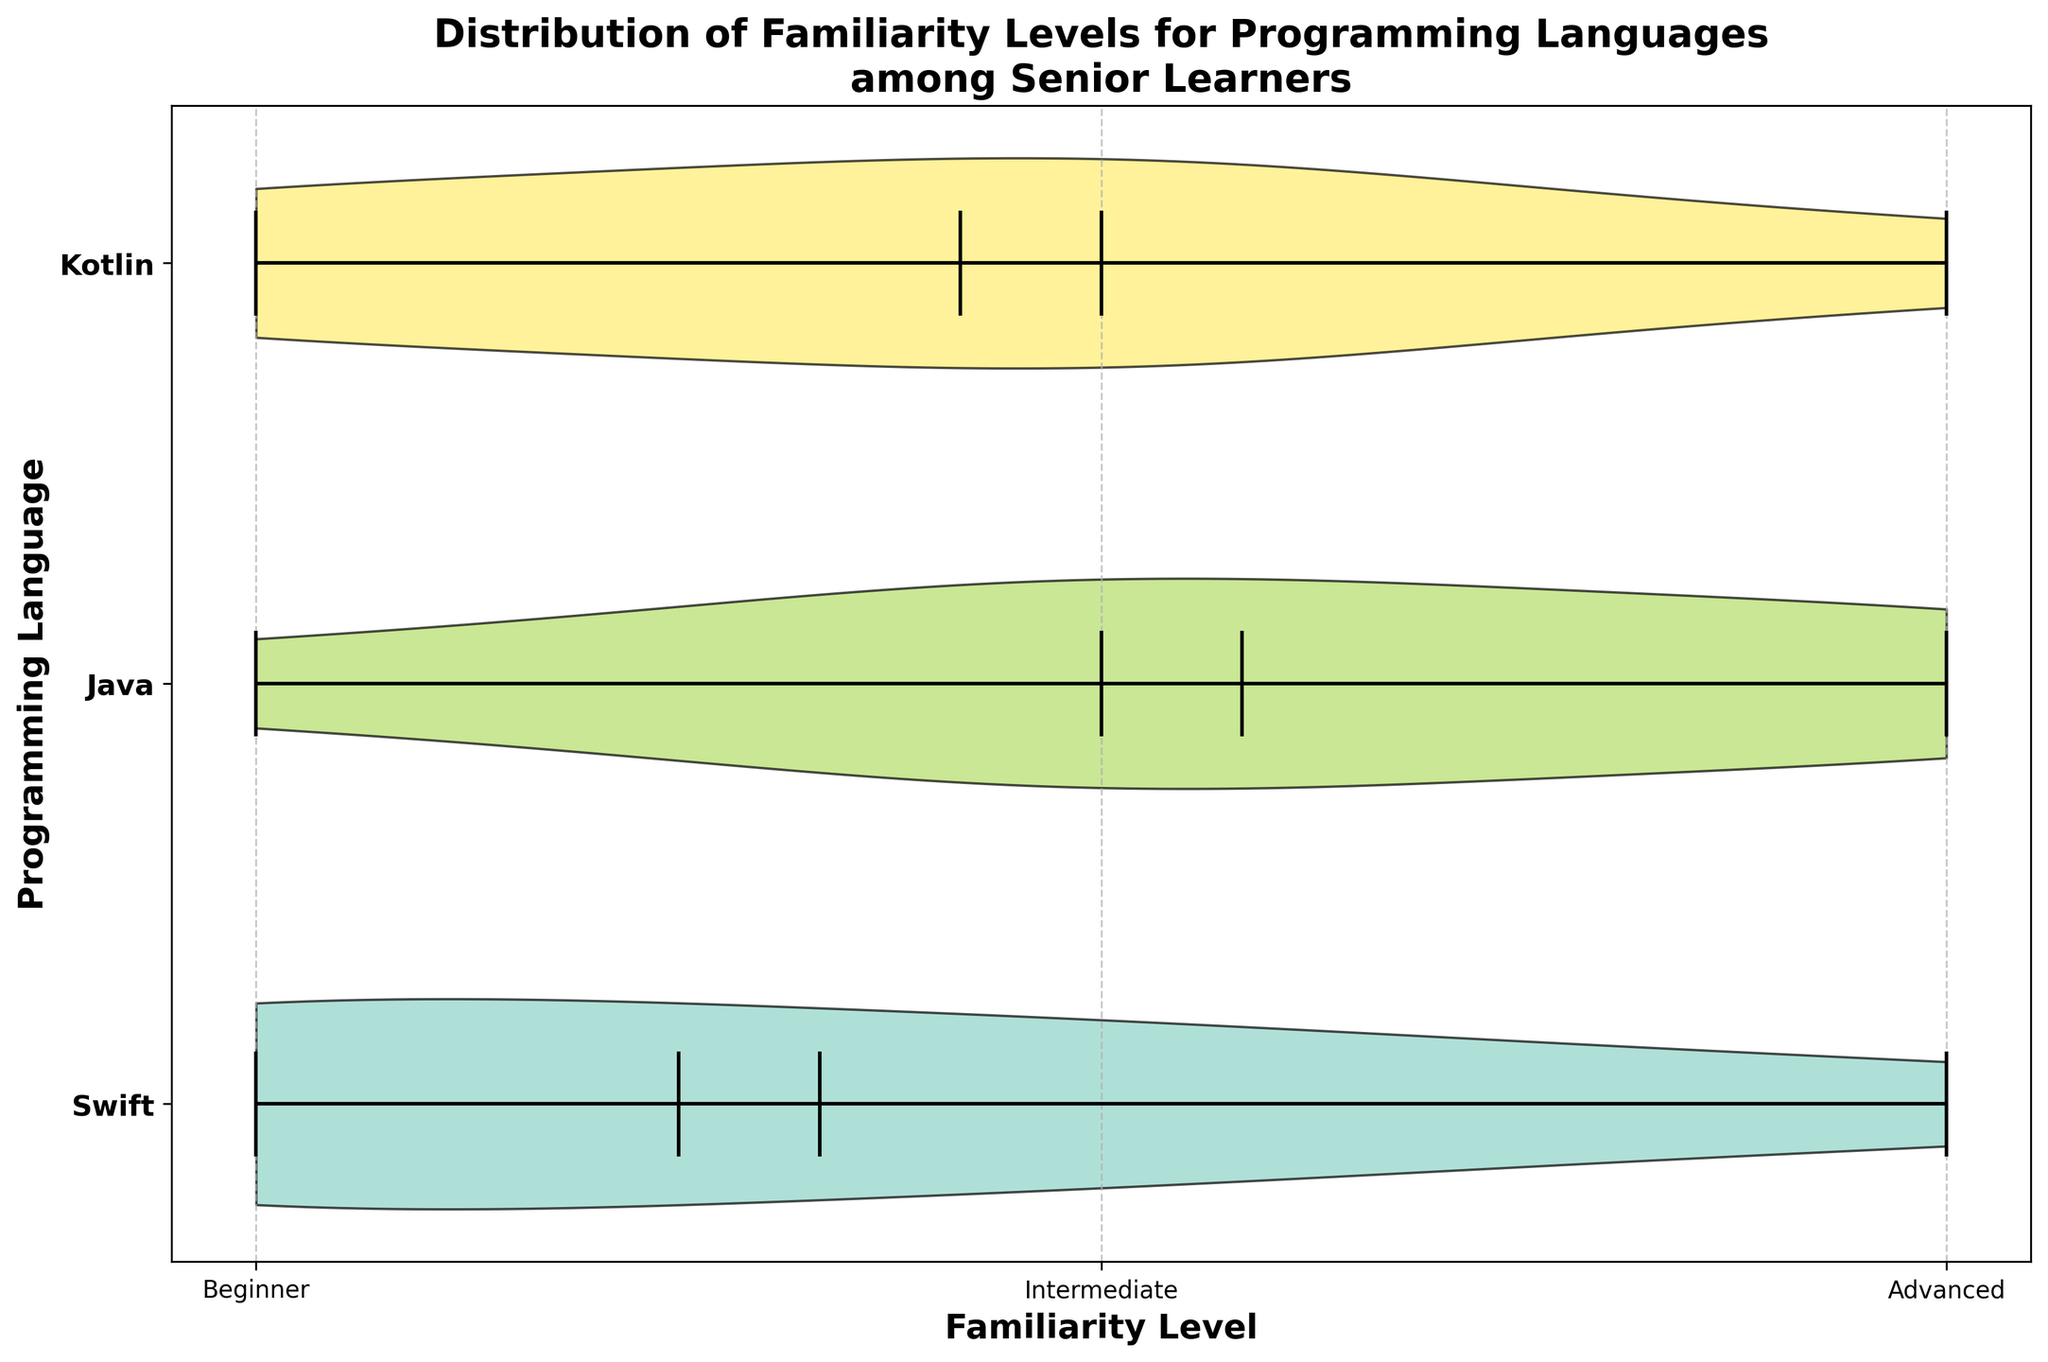What is the title of the chart? The title is shown at the top of the chart. It reads "Distribution of Familiarity Levels for Programming Languages among Senior Learners."
Answer: Distribution of Familiarity Levels for Programming Languages among Senior Learners Which programming language has the widest distribution of familiarity levels? By looking at the range of values on the x-axis for each language's violin plot, Java spans all familiarity levels from Beginner to Advanced.
Answer: Java What is the median familiarity level of Swift? Swift's median is marked by a horizontal line in the violin plot, and it falls at the Intermediate level.
Answer: Intermediate How many levels of familiarity are shown in the chart? The x-axis shows tick marks at three positions, which are labeled Beginner, Intermediate, and Advanced.
Answer: 3 Which programming language has the lowest median familiarity level? The median line within the violin plots shows that Swift has the lowest median at the Intermediate level, while Java and Kotlin both have higher median levels.
Answer: Swift What color is used for the Java violin plot? The colors are assigned from a color palette and visual inspection shows that Java is represented in a pinkish hue.
Answer: Pinkish Which language shows the least variation in familiarity levels? By observing the spread of the violin plots, Swift has the most compact distribution, indicating less variation in familiarity levels among learners.
Answer: Swift Between Kotlin and Swift, which language has more learners at the Advanced level? The width of the violin plot at the Advanced level for Kotlin is wider compared to Swift, indicating that more learners are at the Advanced level in Kotlin.
Answer: Kotlin Is there any language whose learners are almost all at the Intermediate level? By examining the width of the violin plot at the Intermediate level, Java has the most learners in this category, covering the wider portion of its distribution.
Answer: Java Which language appears to have the most consistent familiarity distribution across all levels? As observed from the width and distribution of the violin plots, Swift appears most consistent, with distribution more evenly spread across all levels.
Answer: Swift 